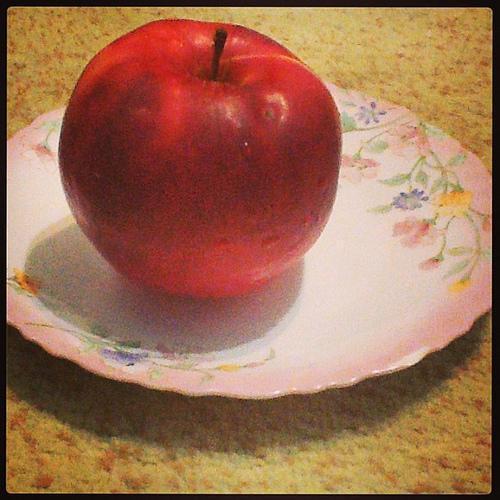How many plates are there?
Give a very brief answer. 1. 